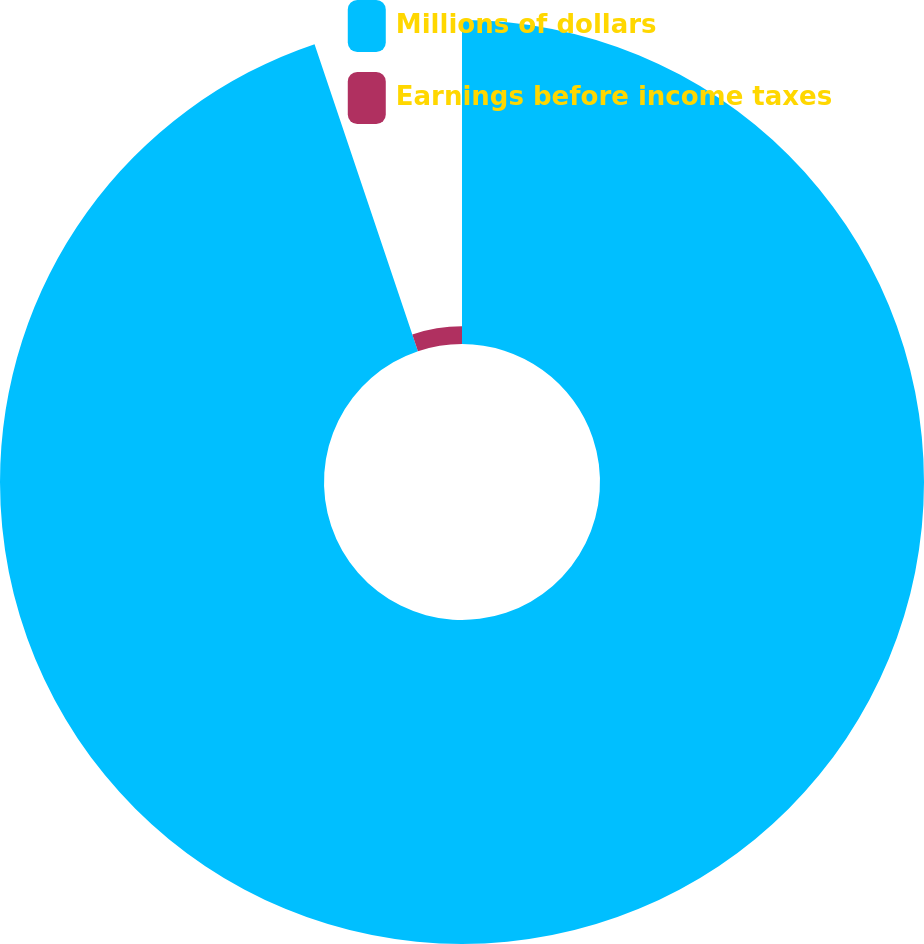Convert chart to OTSL. <chart><loc_0><loc_0><loc_500><loc_500><pie_chart><fcel>Millions of dollars<fcel>Earnings before income taxes<nl><fcel>94.83%<fcel>5.17%<nl></chart> 